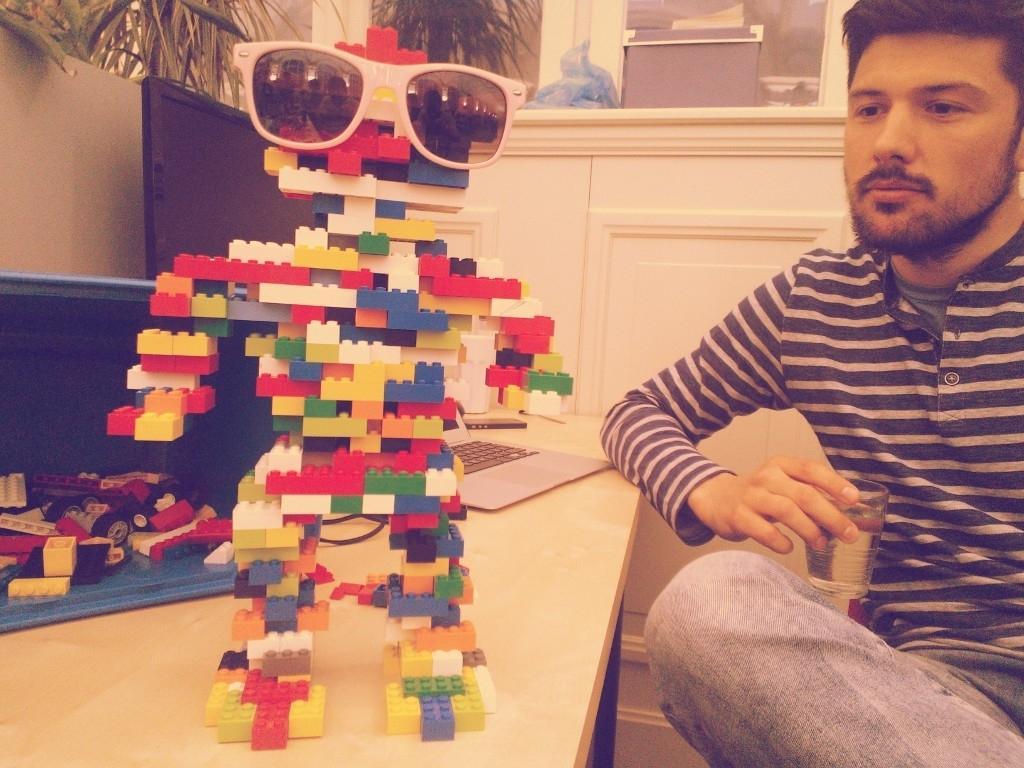Can you describe this image briefly? In this image, this is the man holding a glass and sitting. I can see a monitor, laptop, LEGO puzzle and few other objects on the table. At the top of the image, I think this is a house plant with the leaves. I can see few objects placed near the cupboard. These are the goggles. 